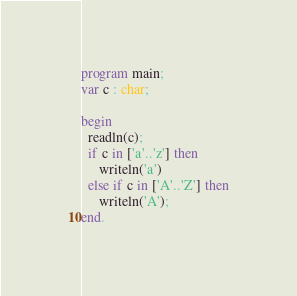<code> <loc_0><loc_0><loc_500><loc_500><_Pascal_>program main;
var c : char;

begin
  readln(c);
  if c in ['a'..'z'] then
     writeln('a')
  else if c in ['A'..'Z'] then
     writeln('A');
end.</code> 